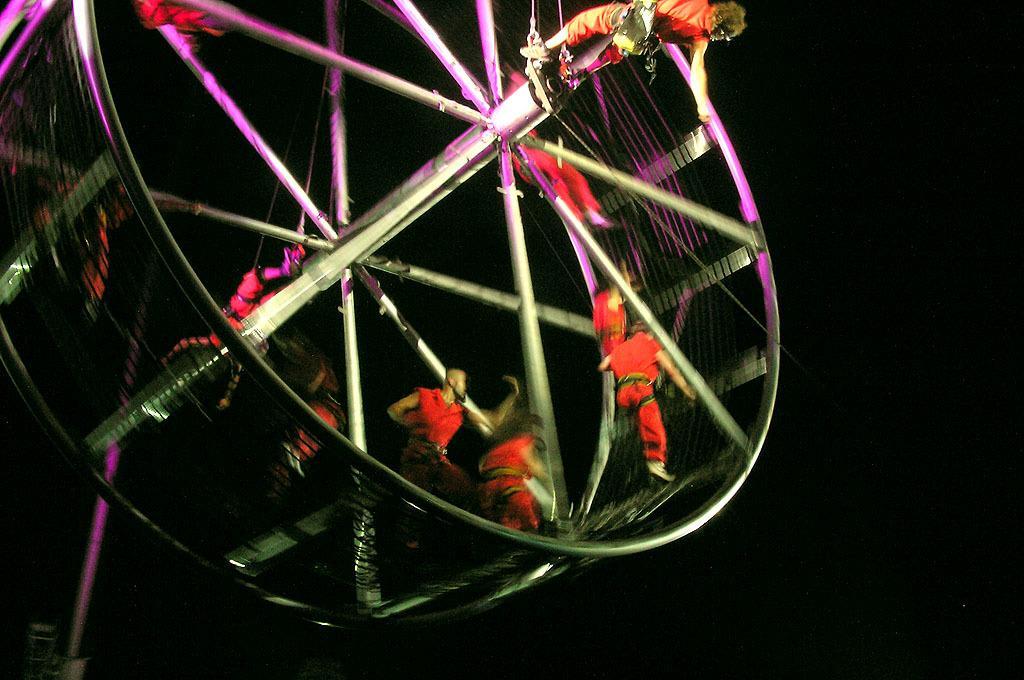How would you summarize this image in a sentence or two? In this image I can see a wheel, on the wheel I can see few persons, they are wearing red color dress. 